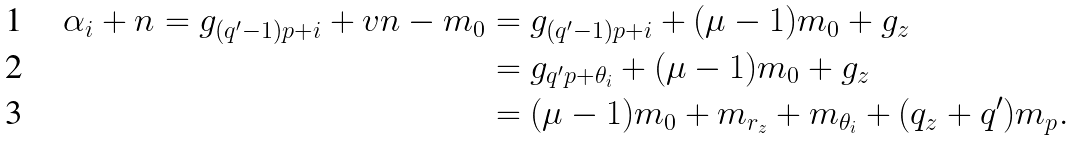Convert formula to latex. <formula><loc_0><loc_0><loc_500><loc_500>\alpha _ { i } + n = g _ { ( q ^ { \prime } - 1 ) p + i } + v n - m _ { 0 } & = g _ { ( q ^ { \prime } - 1 ) p + i } + ( \mu - 1 ) m _ { 0 } + g _ { z } \\ & = g _ { q ^ { \prime } p + \theta _ { i } } + ( \mu - 1 ) m _ { 0 } + g _ { z } \\ & = ( \mu - 1 ) m _ { 0 } + m _ { r _ { z } } + m _ { \theta _ { i } } + ( q _ { z } + q ^ { \prime } ) m _ { p } .</formula> 